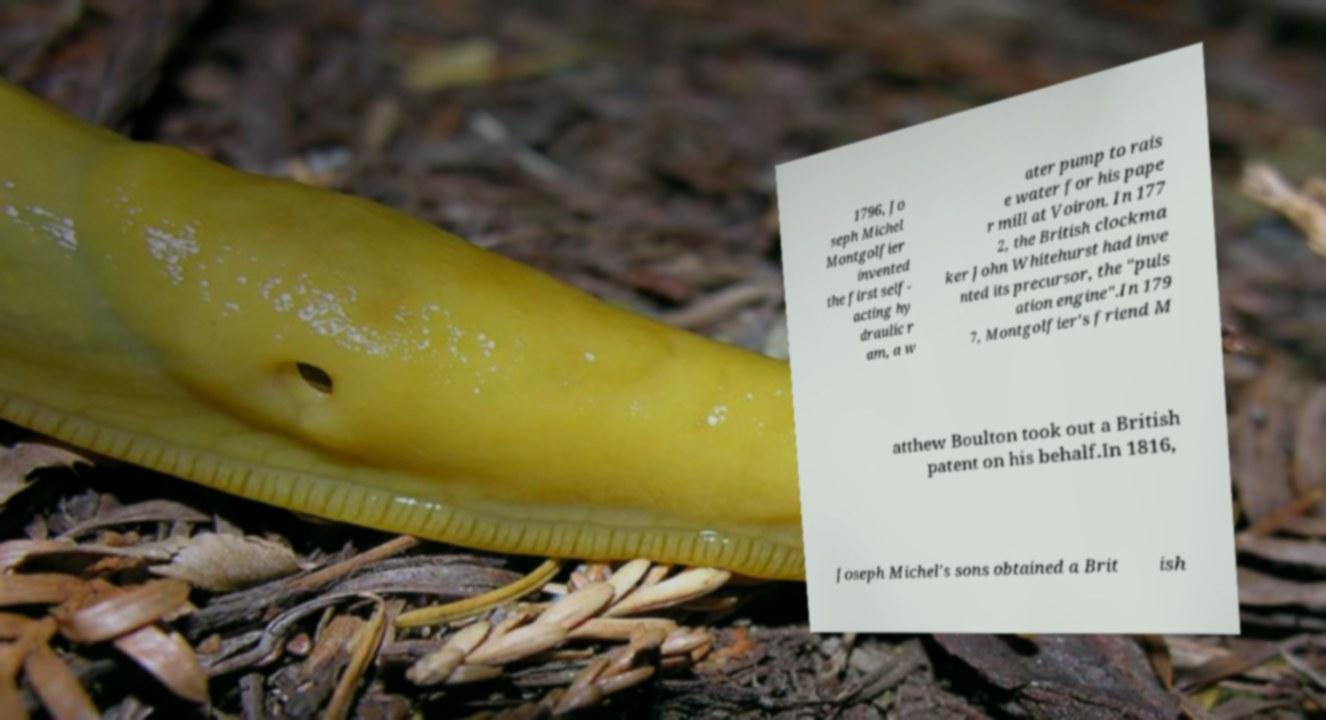Can you accurately transcribe the text from the provided image for me? 1796, Jo seph Michel Montgolfier invented the first self- acting hy draulic r am, a w ater pump to rais e water for his pape r mill at Voiron. In 177 2, the British clockma ker John Whitehurst had inve nted its precursor, the "puls ation engine".In 179 7, Montgolfier's friend M atthew Boulton took out a British patent on his behalf.In 1816, Joseph Michel's sons obtained a Brit ish 